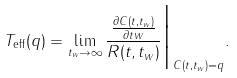<formula> <loc_0><loc_0><loc_500><loc_500>T _ { \text {eff} } ( q ) = \lim _ { t _ { w } \rightarrow \infty } \frac { \frac { \partial C ( t , t _ { w } ) } { \partial t w } } { R ( t , t _ { w } ) } \Big { | } _ { C ( t , t _ { w } ) = q } .</formula> 